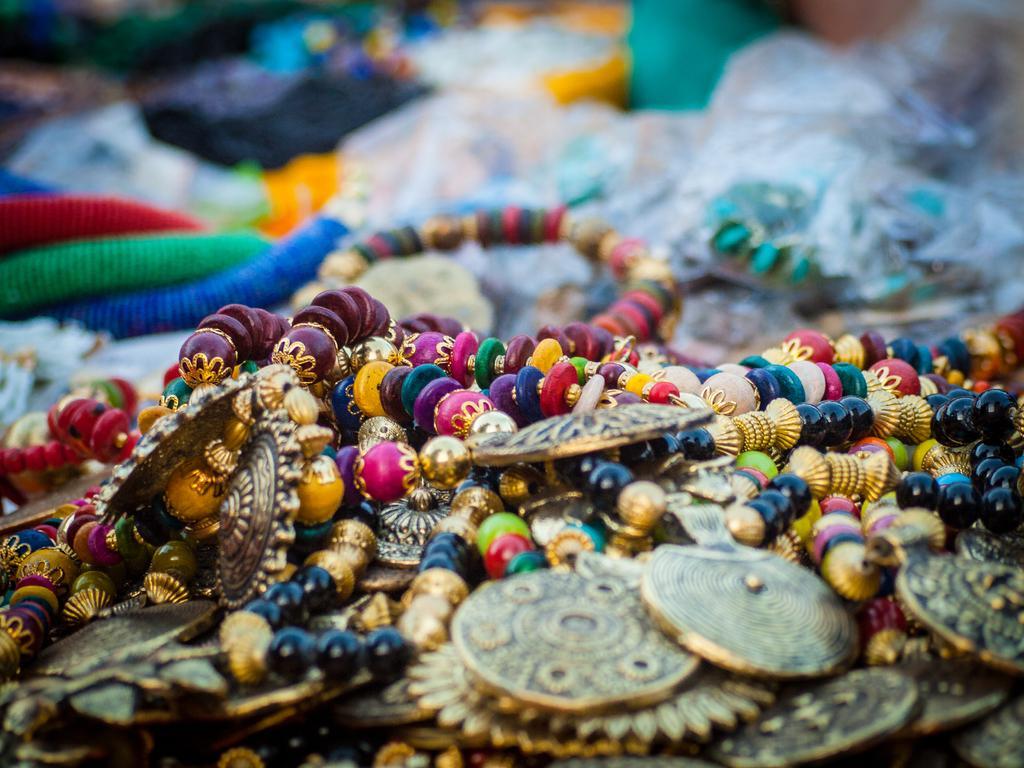Could you give a brief overview of what you see in this image? In this image we can see some jewelry. 